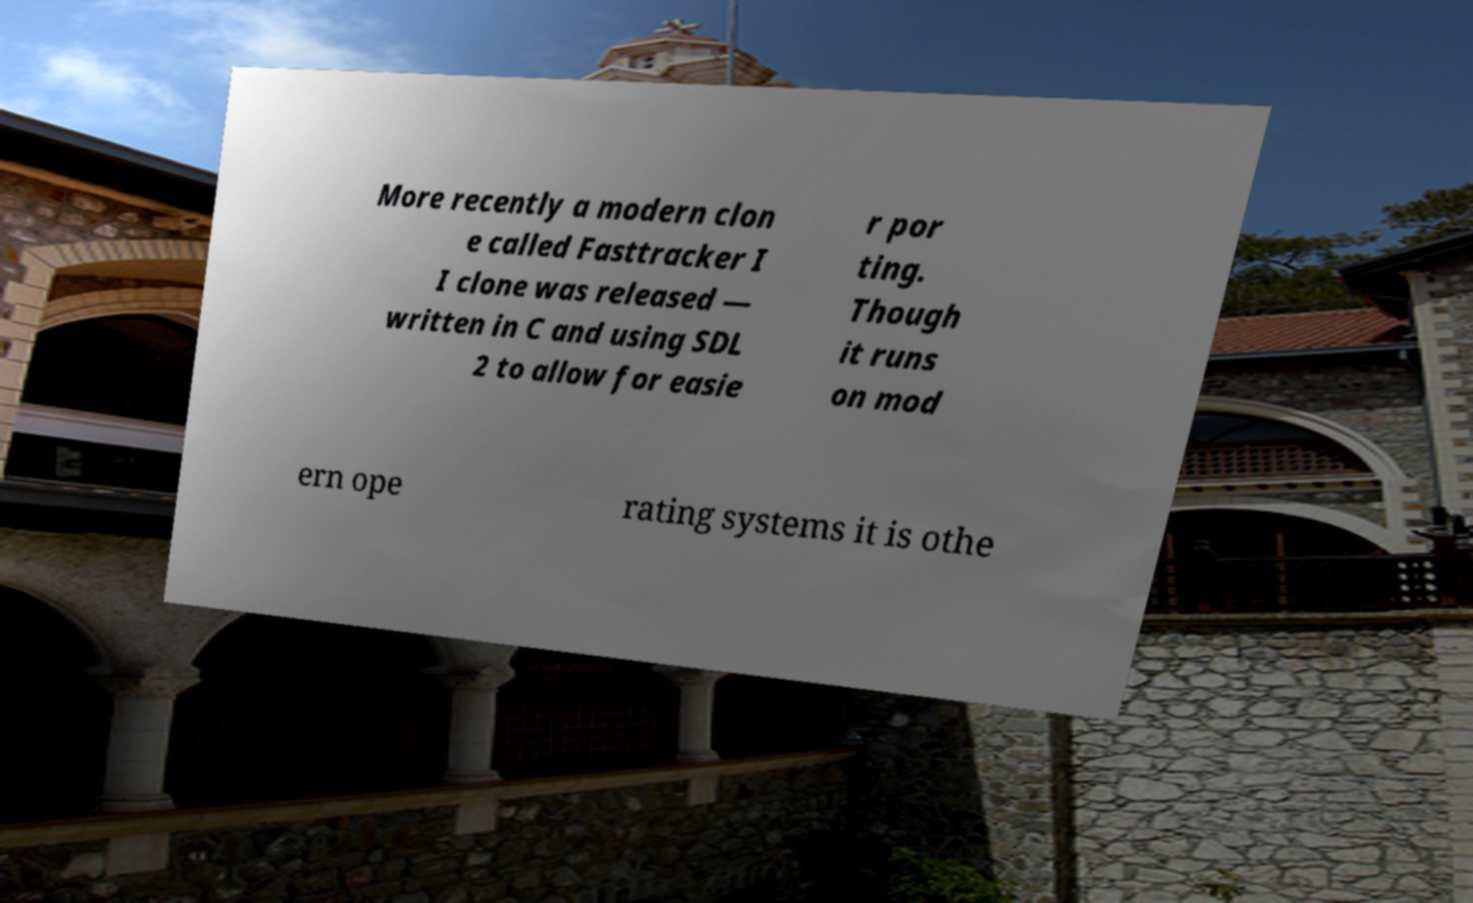Please read and relay the text visible in this image. What does it say? More recently a modern clon e called Fasttracker I I clone was released — written in C and using SDL 2 to allow for easie r por ting. Though it runs on mod ern ope rating systems it is othe 